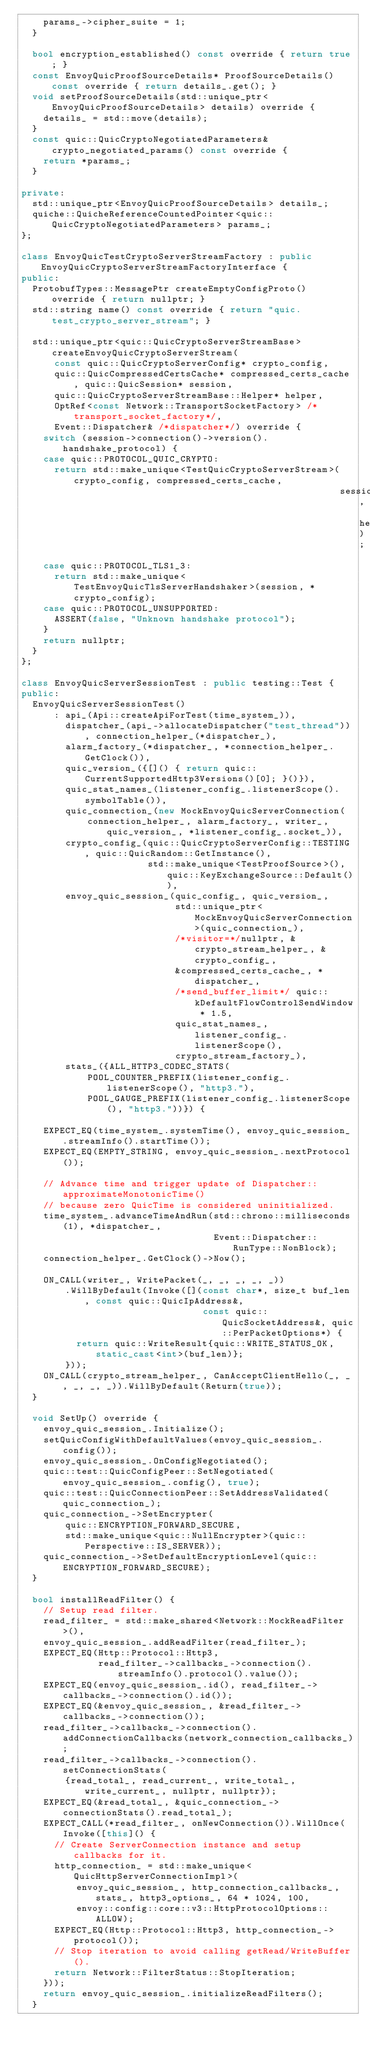<code> <loc_0><loc_0><loc_500><loc_500><_C++_>    params_->cipher_suite = 1;
  }

  bool encryption_established() const override { return true; }
  const EnvoyQuicProofSourceDetails* ProofSourceDetails() const override { return details_.get(); }
  void setProofSourceDetails(std::unique_ptr<EnvoyQuicProofSourceDetails> details) override {
    details_ = std::move(details);
  }
  const quic::QuicCryptoNegotiatedParameters& crypto_negotiated_params() const override {
    return *params_;
  }

private:
  std::unique_ptr<EnvoyQuicProofSourceDetails> details_;
  quiche::QuicheReferenceCountedPointer<quic::QuicCryptoNegotiatedParameters> params_;
};

class EnvoyQuicTestCryptoServerStreamFactory : public EnvoyQuicCryptoServerStreamFactoryInterface {
public:
  ProtobufTypes::MessagePtr createEmptyConfigProto() override { return nullptr; }
  std::string name() const override { return "quic.test_crypto_server_stream"; }

  std::unique_ptr<quic::QuicCryptoServerStreamBase> createEnvoyQuicCryptoServerStream(
      const quic::QuicCryptoServerConfig* crypto_config,
      quic::QuicCompressedCertsCache* compressed_certs_cache, quic::QuicSession* session,
      quic::QuicCryptoServerStreamBase::Helper* helper,
      OptRef<const Network::TransportSocketFactory> /*transport_socket_factory*/,
      Event::Dispatcher& /*dispatcher*/) override {
    switch (session->connection()->version().handshake_protocol) {
    case quic::PROTOCOL_QUIC_CRYPTO:
      return std::make_unique<TestQuicCryptoServerStream>(crypto_config, compressed_certs_cache,
                                                          session, helper);
    case quic::PROTOCOL_TLS1_3:
      return std::make_unique<TestEnvoyQuicTlsServerHandshaker>(session, *crypto_config);
    case quic::PROTOCOL_UNSUPPORTED:
      ASSERT(false, "Unknown handshake protocol");
    }
    return nullptr;
  }
};

class EnvoyQuicServerSessionTest : public testing::Test {
public:
  EnvoyQuicServerSessionTest()
      : api_(Api::createApiForTest(time_system_)),
        dispatcher_(api_->allocateDispatcher("test_thread")), connection_helper_(*dispatcher_),
        alarm_factory_(*dispatcher_, *connection_helper_.GetClock()),
        quic_version_({[]() { return quic::CurrentSupportedHttp3Versions()[0]; }()}),
        quic_stat_names_(listener_config_.listenerScope().symbolTable()),
        quic_connection_(new MockEnvoyQuicServerConnection(
            connection_helper_, alarm_factory_, writer_, quic_version_, *listener_config_.socket_)),
        crypto_config_(quic::QuicCryptoServerConfig::TESTING, quic::QuicRandom::GetInstance(),
                       std::make_unique<TestProofSource>(), quic::KeyExchangeSource::Default()),
        envoy_quic_session_(quic_config_, quic_version_,
                            std::unique_ptr<MockEnvoyQuicServerConnection>(quic_connection_),
                            /*visitor=*/nullptr, &crypto_stream_helper_, &crypto_config_,
                            &compressed_certs_cache_, *dispatcher_,
                            /*send_buffer_limit*/ quic::kDefaultFlowControlSendWindow * 1.5,
                            quic_stat_names_, listener_config_.listenerScope(),
                            crypto_stream_factory_),
        stats_({ALL_HTTP3_CODEC_STATS(
            POOL_COUNTER_PREFIX(listener_config_.listenerScope(), "http3."),
            POOL_GAUGE_PREFIX(listener_config_.listenerScope(), "http3."))}) {

    EXPECT_EQ(time_system_.systemTime(), envoy_quic_session_.streamInfo().startTime());
    EXPECT_EQ(EMPTY_STRING, envoy_quic_session_.nextProtocol());

    // Advance time and trigger update of Dispatcher::approximateMonotonicTime()
    // because zero QuicTime is considered uninitialized.
    time_system_.advanceTimeAndRun(std::chrono::milliseconds(1), *dispatcher_,
                                   Event::Dispatcher::RunType::NonBlock);
    connection_helper_.GetClock()->Now();

    ON_CALL(writer_, WritePacket(_, _, _, _, _))
        .WillByDefault(Invoke([](const char*, size_t buf_len, const quic::QuicIpAddress&,
                                 const quic::QuicSocketAddress&, quic::PerPacketOptions*) {
          return quic::WriteResult{quic::WRITE_STATUS_OK, static_cast<int>(buf_len)};
        }));
    ON_CALL(crypto_stream_helper_, CanAcceptClientHello(_, _, _, _, _)).WillByDefault(Return(true));
  }

  void SetUp() override {
    envoy_quic_session_.Initialize();
    setQuicConfigWithDefaultValues(envoy_quic_session_.config());
    envoy_quic_session_.OnConfigNegotiated();
    quic::test::QuicConfigPeer::SetNegotiated(envoy_quic_session_.config(), true);
    quic::test::QuicConnectionPeer::SetAddressValidated(quic_connection_);
    quic_connection_->SetEncrypter(
        quic::ENCRYPTION_FORWARD_SECURE,
        std::make_unique<quic::NullEncrypter>(quic::Perspective::IS_SERVER));
    quic_connection_->SetDefaultEncryptionLevel(quic::ENCRYPTION_FORWARD_SECURE);
  }

  bool installReadFilter() {
    // Setup read filter.
    read_filter_ = std::make_shared<Network::MockReadFilter>(),
    envoy_quic_session_.addReadFilter(read_filter_);
    EXPECT_EQ(Http::Protocol::Http3,
              read_filter_->callbacks_->connection().streamInfo().protocol().value());
    EXPECT_EQ(envoy_quic_session_.id(), read_filter_->callbacks_->connection().id());
    EXPECT_EQ(&envoy_quic_session_, &read_filter_->callbacks_->connection());
    read_filter_->callbacks_->connection().addConnectionCallbacks(network_connection_callbacks_);
    read_filter_->callbacks_->connection().setConnectionStats(
        {read_total_, read_current_, write_total_, write_current_, nullptr, nullptr});
    EXPECT_EQ(&read_total_, &quic_connection_->connectionStats().read_total_);
    EXPECT_CALL(*read_filter_, onNewConnection()).WillOnce(Invoke([this]() {
      // Create ServerConnection instance and setup callbacks for it.
      http_connection_ = std::make_unique<QuicHttpServerConnectionImpl>(
          envoy_quic_session_, http_connection_callbacks_, stats_, http3_options_, 64 * 1024, 100,
          envoy::config::core::v3::HttpProtocolOptions::ALLOW);
      EXPECT_EQ(Http::Protocol::Http3, http_connection_->protocol());
      // Stop iteration to avoid calling getRead/WriteBuffer().
      return Network::FilterStatus::StopIteration;
    }));
    return envoy_quic_session_.initializeReadFilters();
  }
</code> 